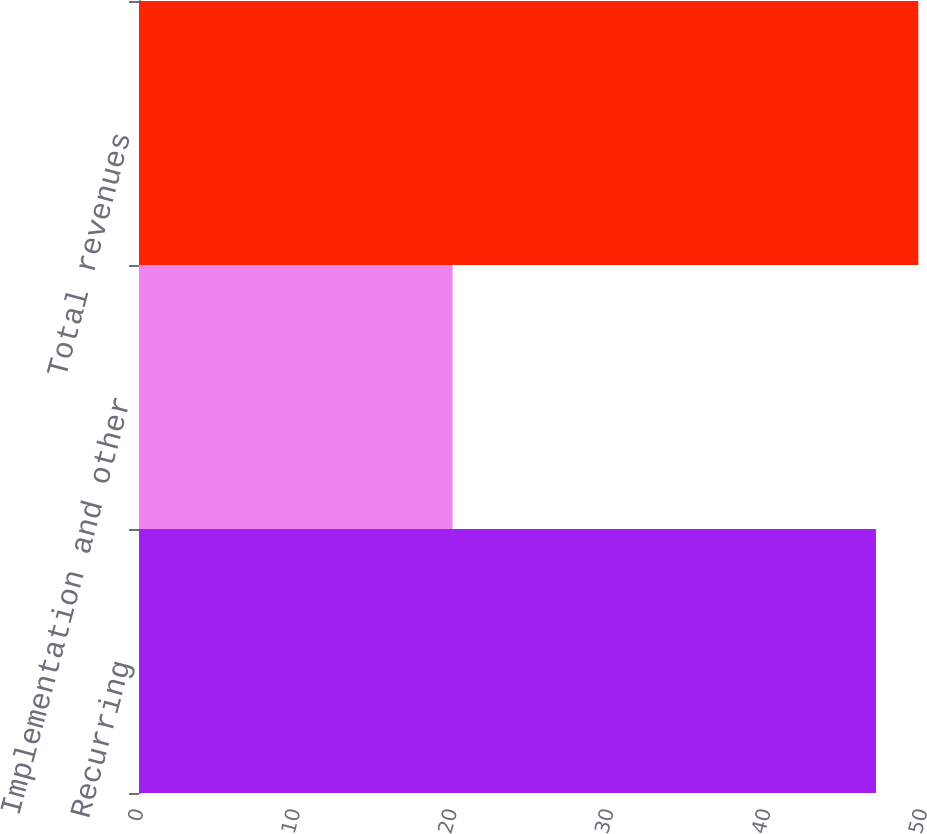Convert chart to OTSL. <chart><loc_0><loc_0><loc_500><loc_500><bar_chart><fcel>Recurring<fcel>Implementation and other<fcel>Total revenues<nl><fcel>47<fcel>20<fcel>49.7<nl></chart> 